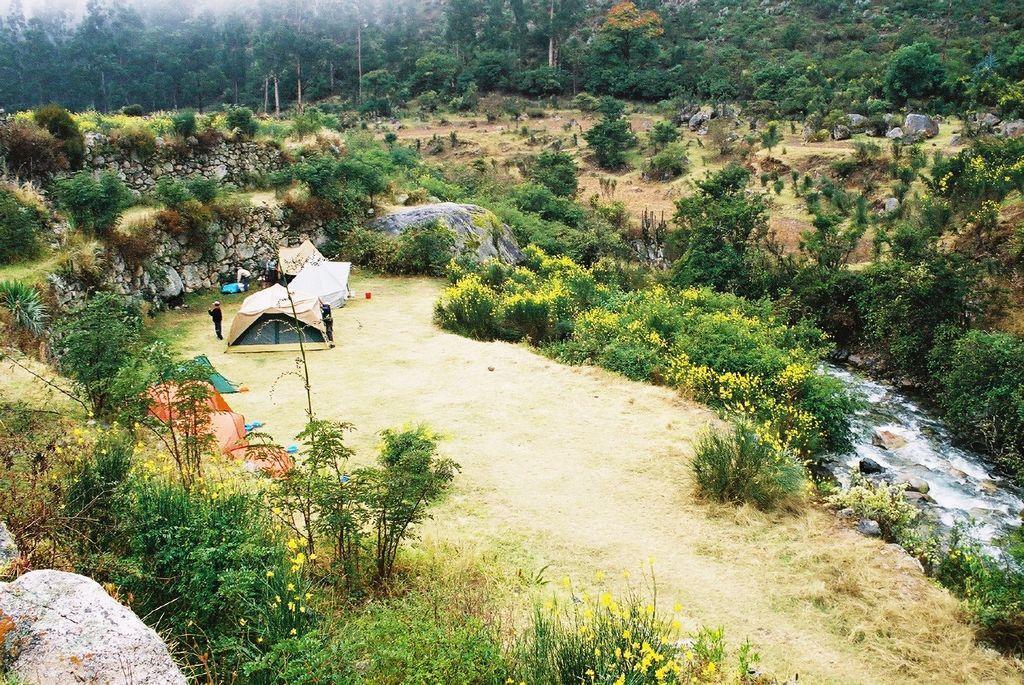Please provide a concise description of this image. In this image there are tents on the grassland. There are people on the grassland. Right side there is water. Background there are trees and plants on the land. Bottom of the image there are plants having flowers. 